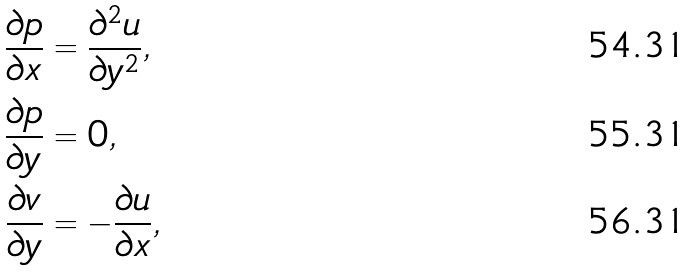Convert formula to latex. <formula><loc_0><loc_0><loc_500><loc_500>\frac { \partial p } { \partial x } & = \frac { \partial ^ { 2 } u } { \partial y ^ { 2 } } , \\ \frac { \partial p } { \partial y } & = 0 , \\ \frac { \partial v } { \partial y } & = - \frac { \partial u } { \partial x } ,</formula> 